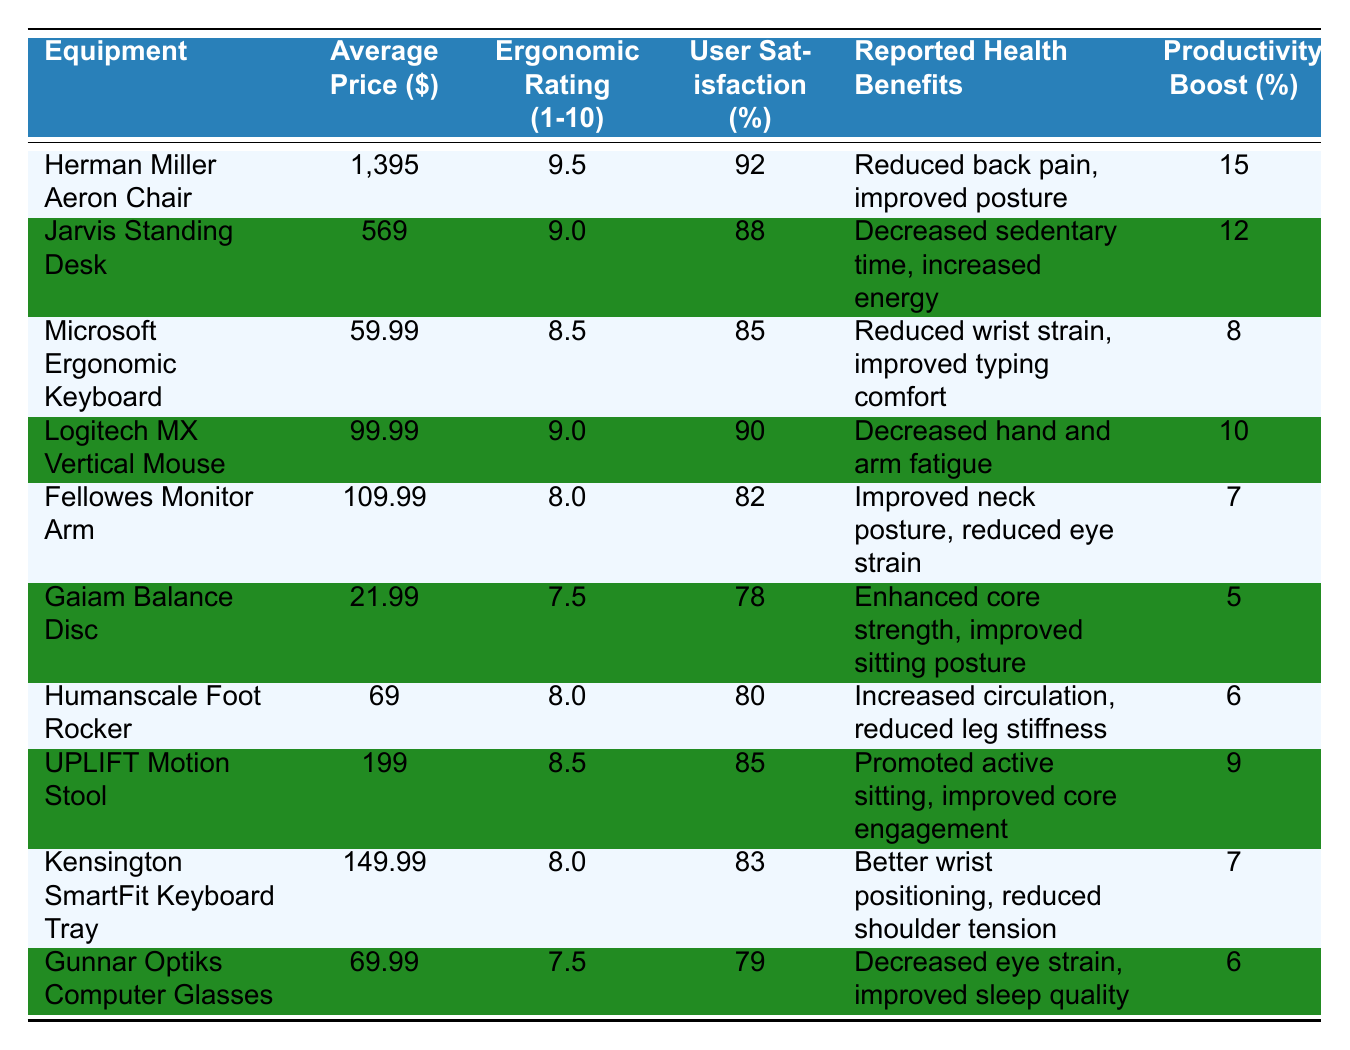What is the most expensive ergonomic equipment listed? The table lists the prices of various ergonomic equipment. Comparing the prices, the "Herman Miller Aeron Chair" has the highest price at $1395.
Answer: Herman Miller Aeron Chair Which equipment has the highest ergonomic rating? The "Herman Miller Aeron Chair" has an ergonomic rating of 9.5, which is the highest when compared to all other equipment listed.
Answer: 9.5 What is the reported health benefit of using the "Logitech MX Vertical Mouse"? According to the table, the "Logitech MX Vertical Mouse" is reported to decrease hand and arm fatigue as a health benefit.
Answer: Decreased hand and arm fatigue Calculate the average user satisfaction percentage of all the equipment listed. The user satisfaction percentages are: 92, 88, 85, 90, 82, 78, 80, 85, 83, 79. The sum is 88.7, so the average is 88.7/10 = 88.7.
Answer: 88.7 Is the "Gunnar Optiks Computer Glasses" rated above 8 for ergonomics? The ergonomic rating for the "Gunnar Optiks Computer Glasses" is 7.5, which is below the rating of 8.
Answer: No Which equipment offers the least productivity boost? The "Gaiam Balance Disc" shows a productivity boost of only 5%, which is the smallest boost listed in the table.
Answer: Gaiam Balance Disc What is the difference in average price between the "Jarvis Standing Desk" and the "Gaiam Balance Disc"? Subtract the price of the "Gaiam Balance Disc" ($21.99) from the "Jarvis Standing Desk" ($569). The difference is $569 - $21.99 = $547.01.
Answer: $547.01 Which equipment has the highest user satisfaction and what is the percentage? The "Herman Miller Aeron Chair" has the highest user satisfaction at 92%.
Answer: 92% Are there any equipment options with an ergonomic rating of 8 or higher that also have a productivity boost of over 10%? Yes, the "Herman Miller Aeron Chair", "Jarvis Standing Desk", and "Logitech MX Vertical Mouse" have ratings of 8 or higher and boost productivity over 10%.
Answer: Yes Find the average ergonomic rating for all equipment. The ergonomic ratings are 9.5, 9.0, 8.5, 9.0, 8.0, 7.5, 8.0, 8.5, 8.0, and 7.5. The sum is 8.4, so the average is 8.4 / 10 = 8.4.
Answer: 8.4 